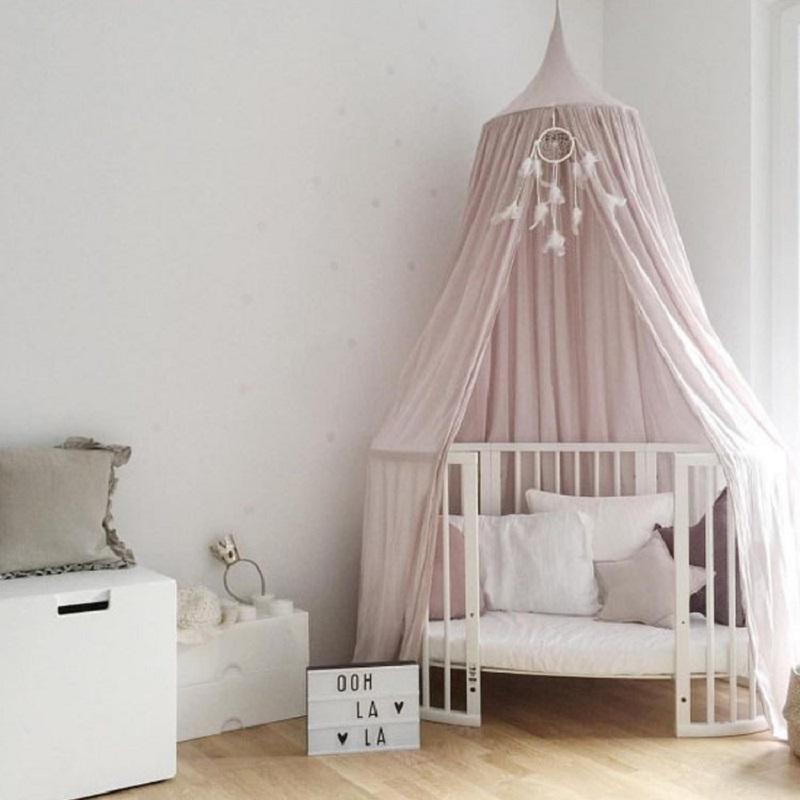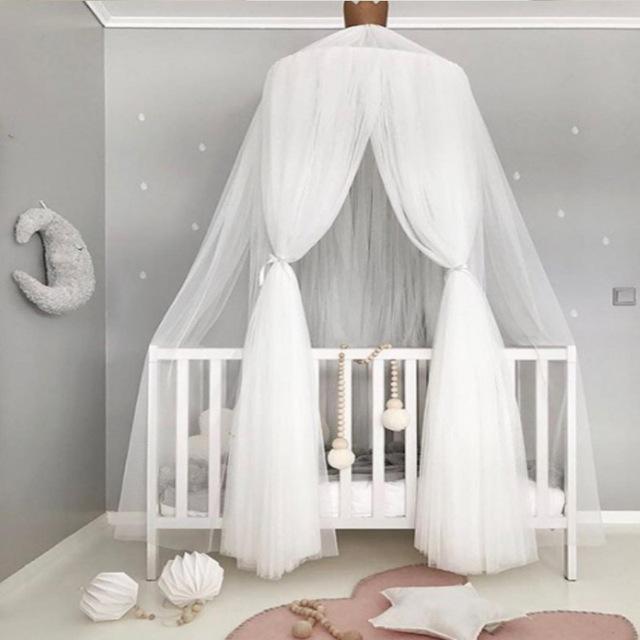The first image is the image on the left, the second image is the image on the right. Considering the images on both sides, is "There is exactly one crib with netting above it." valid? Answer yes or no. No. 